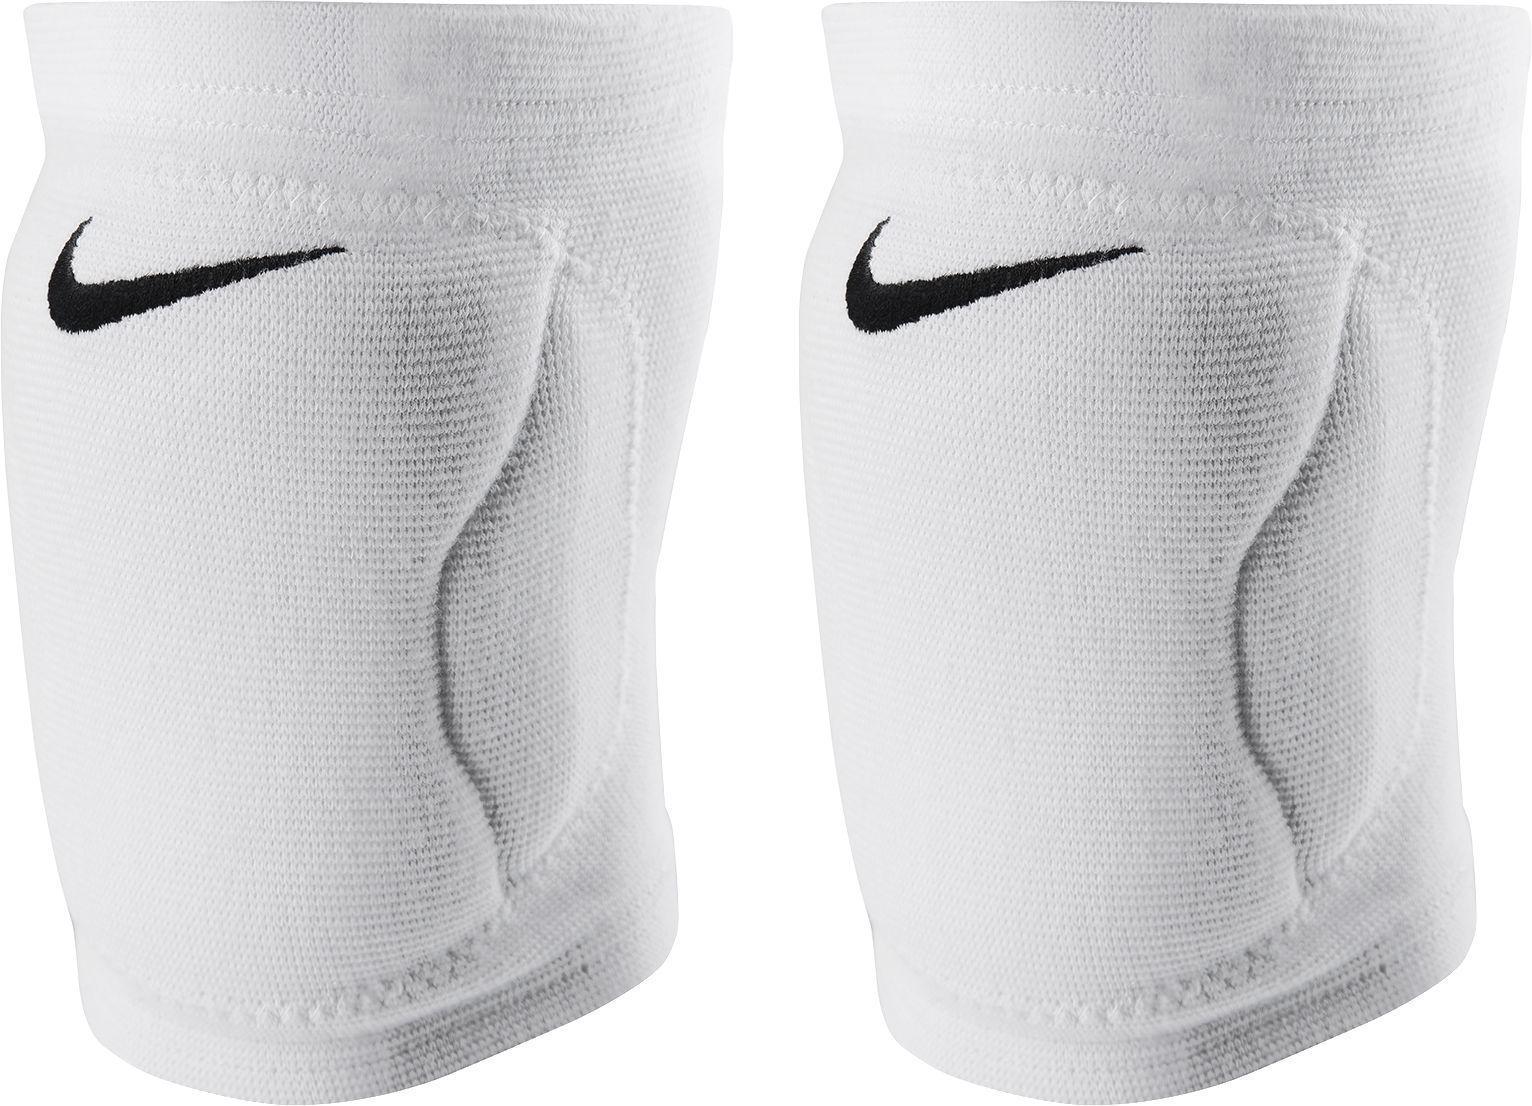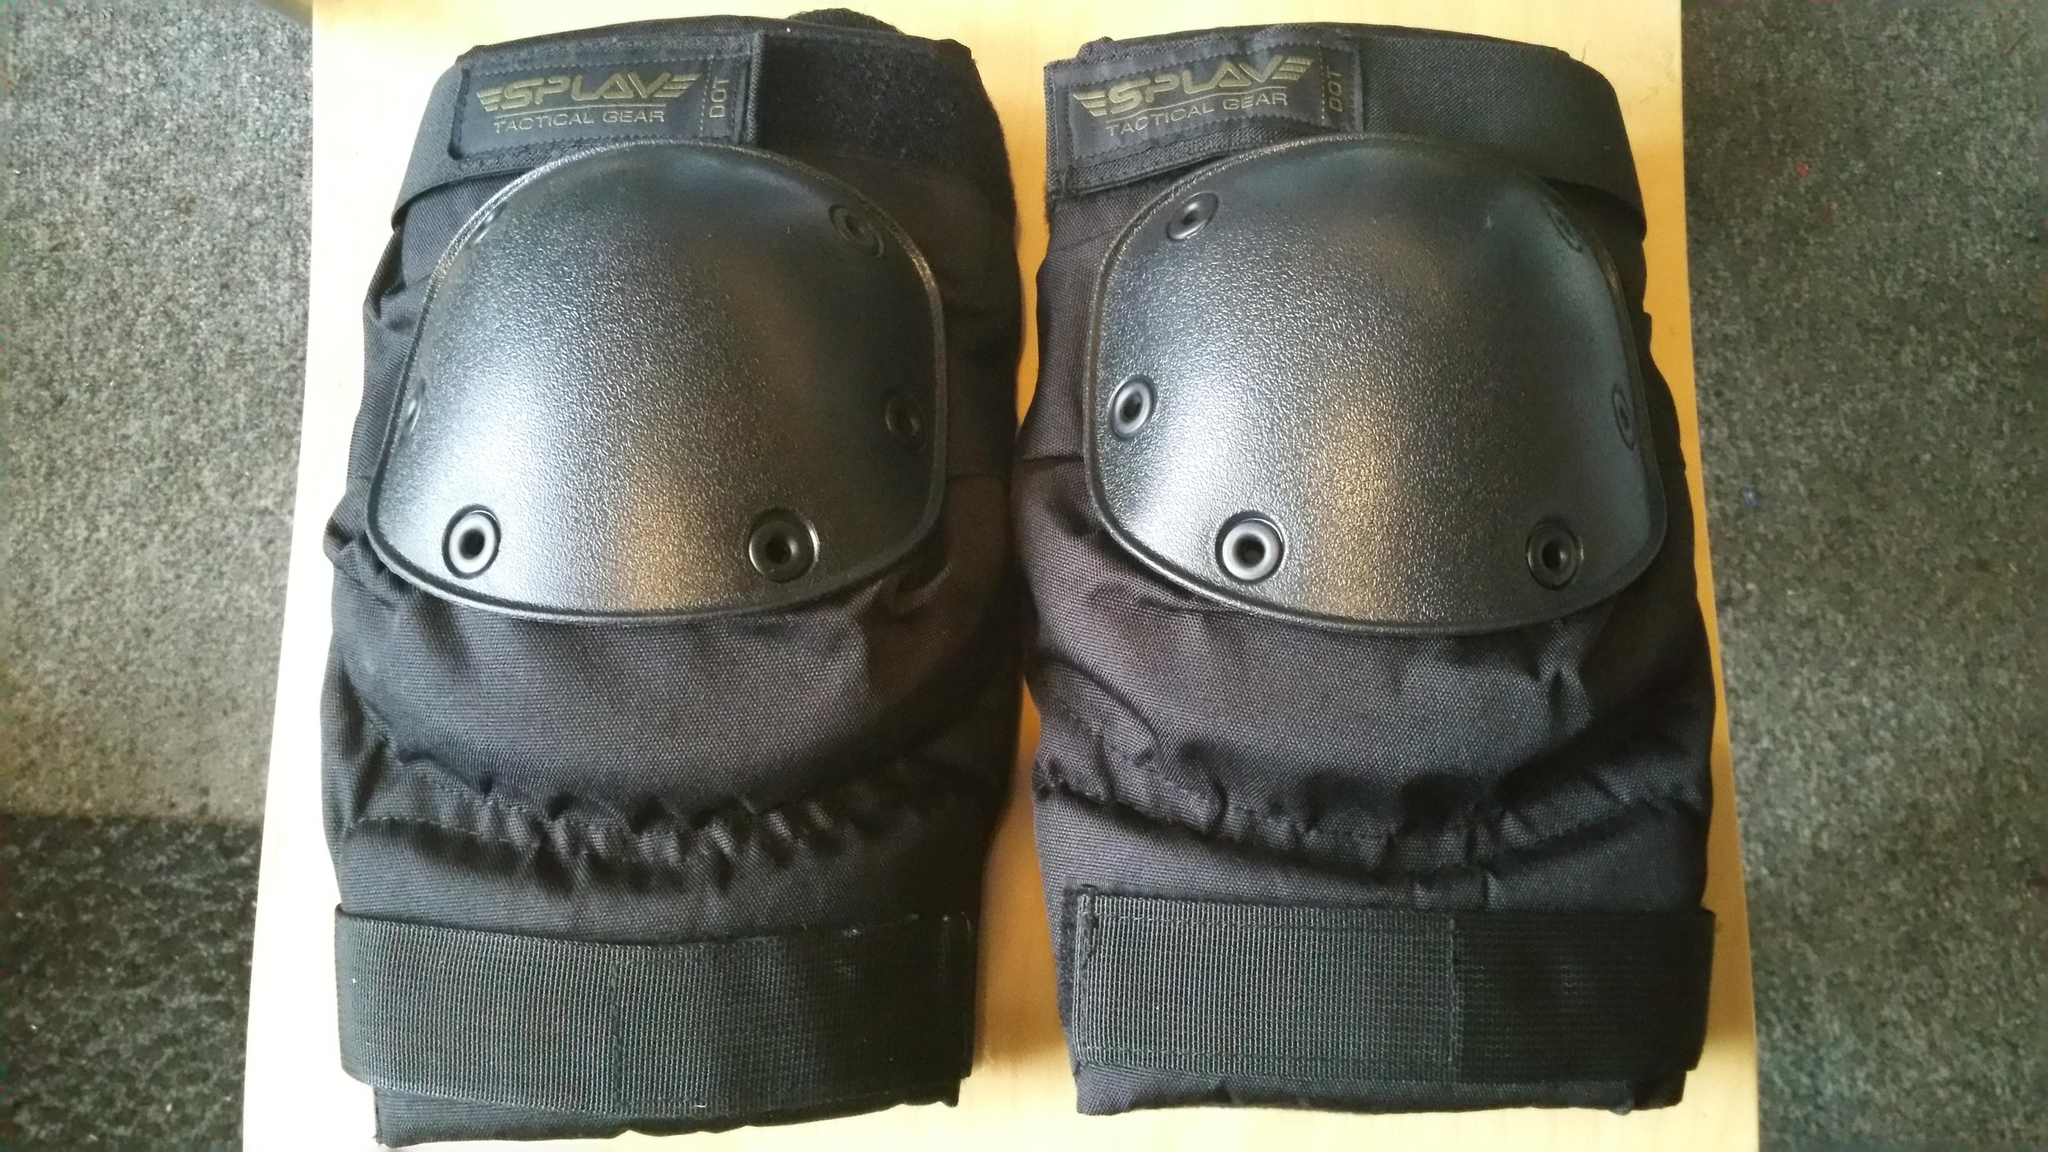The first image is the image on the left, the second image is the image on the right. Considering the images on both sides, is "The knee pads in the image on the right have no white markings." valid? Answer yes or no. Yes. The first image is the image on the left, the second image is the image on the right. Analyze the images presented: Is the assertion "An image shows a pair of unworn, smooth black kneepads with no texture turned rightward." valid? Answer yes or no. No. 